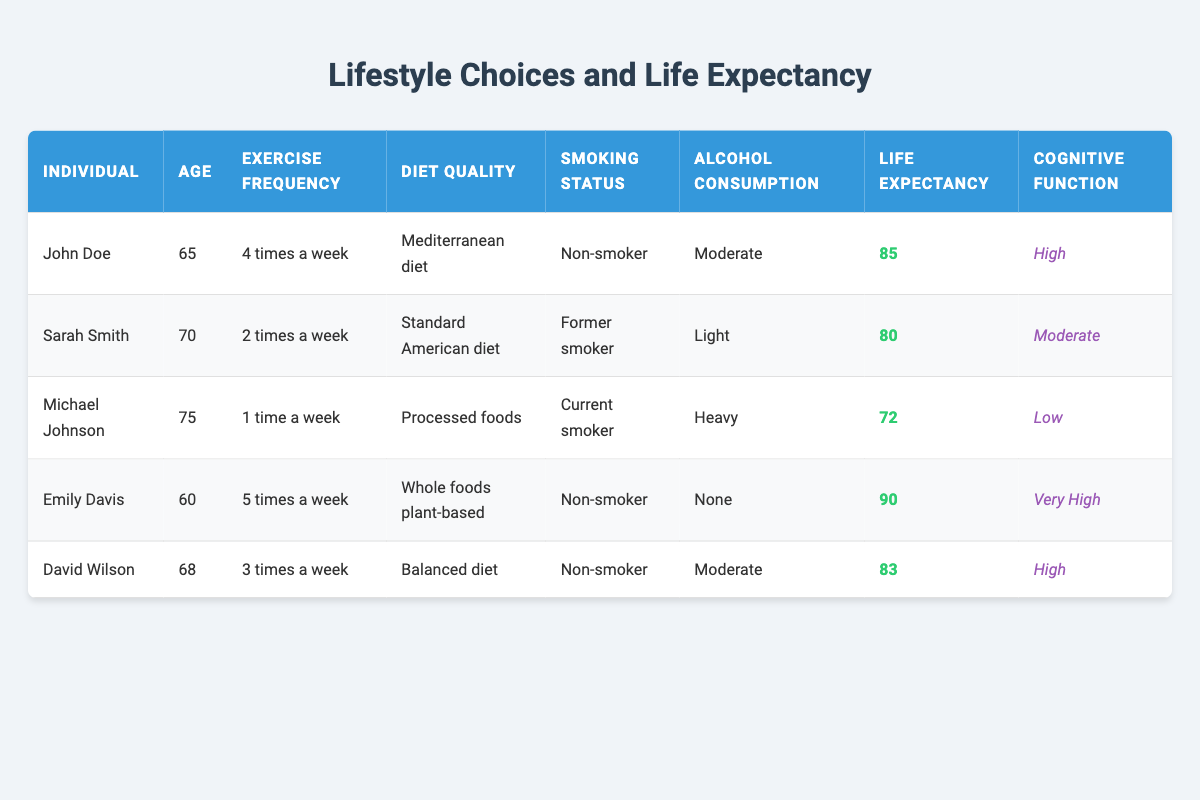What is the life expectancy of Emily Davis? Emily Davis's life expectancy is clearly stated in the table, where it says she is expected to live until 90.
Answer: 90 What diet quality does John Doe follow? The table specifies John Doe's diet quality as "Mediterranean diet."
Answer: Mediterranean diet Is Sarah Smith a current smoker? The table indicates that Sarah Smith is a former smoker, not a current smoker, therefore the statement is false.
Answer: No Who has the highest cognitive function? By analyzing the cognitive function data in the table, it is clear that Emily Davis has the highest cognitive function categorized as "Very High."
Answer: Emily Davis What is the average life expectancy of the individuals listed in the table? To find the average life expectancy, sum the life expectancies (85 + 80 + 72 + 90 + 83 = 410) and divide by the number of individuals (5), resulting in an average of 410/5 = 82.
Answer: 82 Does moderate alcohol consumption correlate with higher cognitive function? By comparing the individuals with moderate alcohol consumption, we find two: John Doe (High cognitive function) and David Wilson (High cognitive function). However, this isn't enough evidence to conclude that moderate alcohol consumption correlates with higher cognitive function since further data is needed for a definitive answer.
Answer: No What is the difference in life expectancy between Michael Johnson and David Wilson? From the table, Michael Johnson's life expectancy is 72 and David Wilson's is 83. The difference is calculated as 83 - 72, which equals 11.
Answer: 11 How many individuals exercise more than 3 times a week? There are three individuals who exercise more than 3 times a week: Emily Davis (5 times a week), John Doe (4 times a week), and David Wilson (3 times a week). This totals to three individuals.
Answer: 3 What lifestyle choices does Michael Johnson have that contribute to a low life expectancy? Analyzing the table, Michael Johnson's low life expectancy (72) correlates with multiple negative lifestyle choices: he exercises only 1 time a week, follows a diet mostly of processed foods, is a current smoker, and has heavy alcohol consumption.
Answer: Negative lifestyle choices Is there any individual in the table who follows a whole foods plant-based diet? The table states that Emily Davis follows a whole foods plant-based diet, confirming that there is indeed at least one individual who follows this diet.
Answer: Yes 